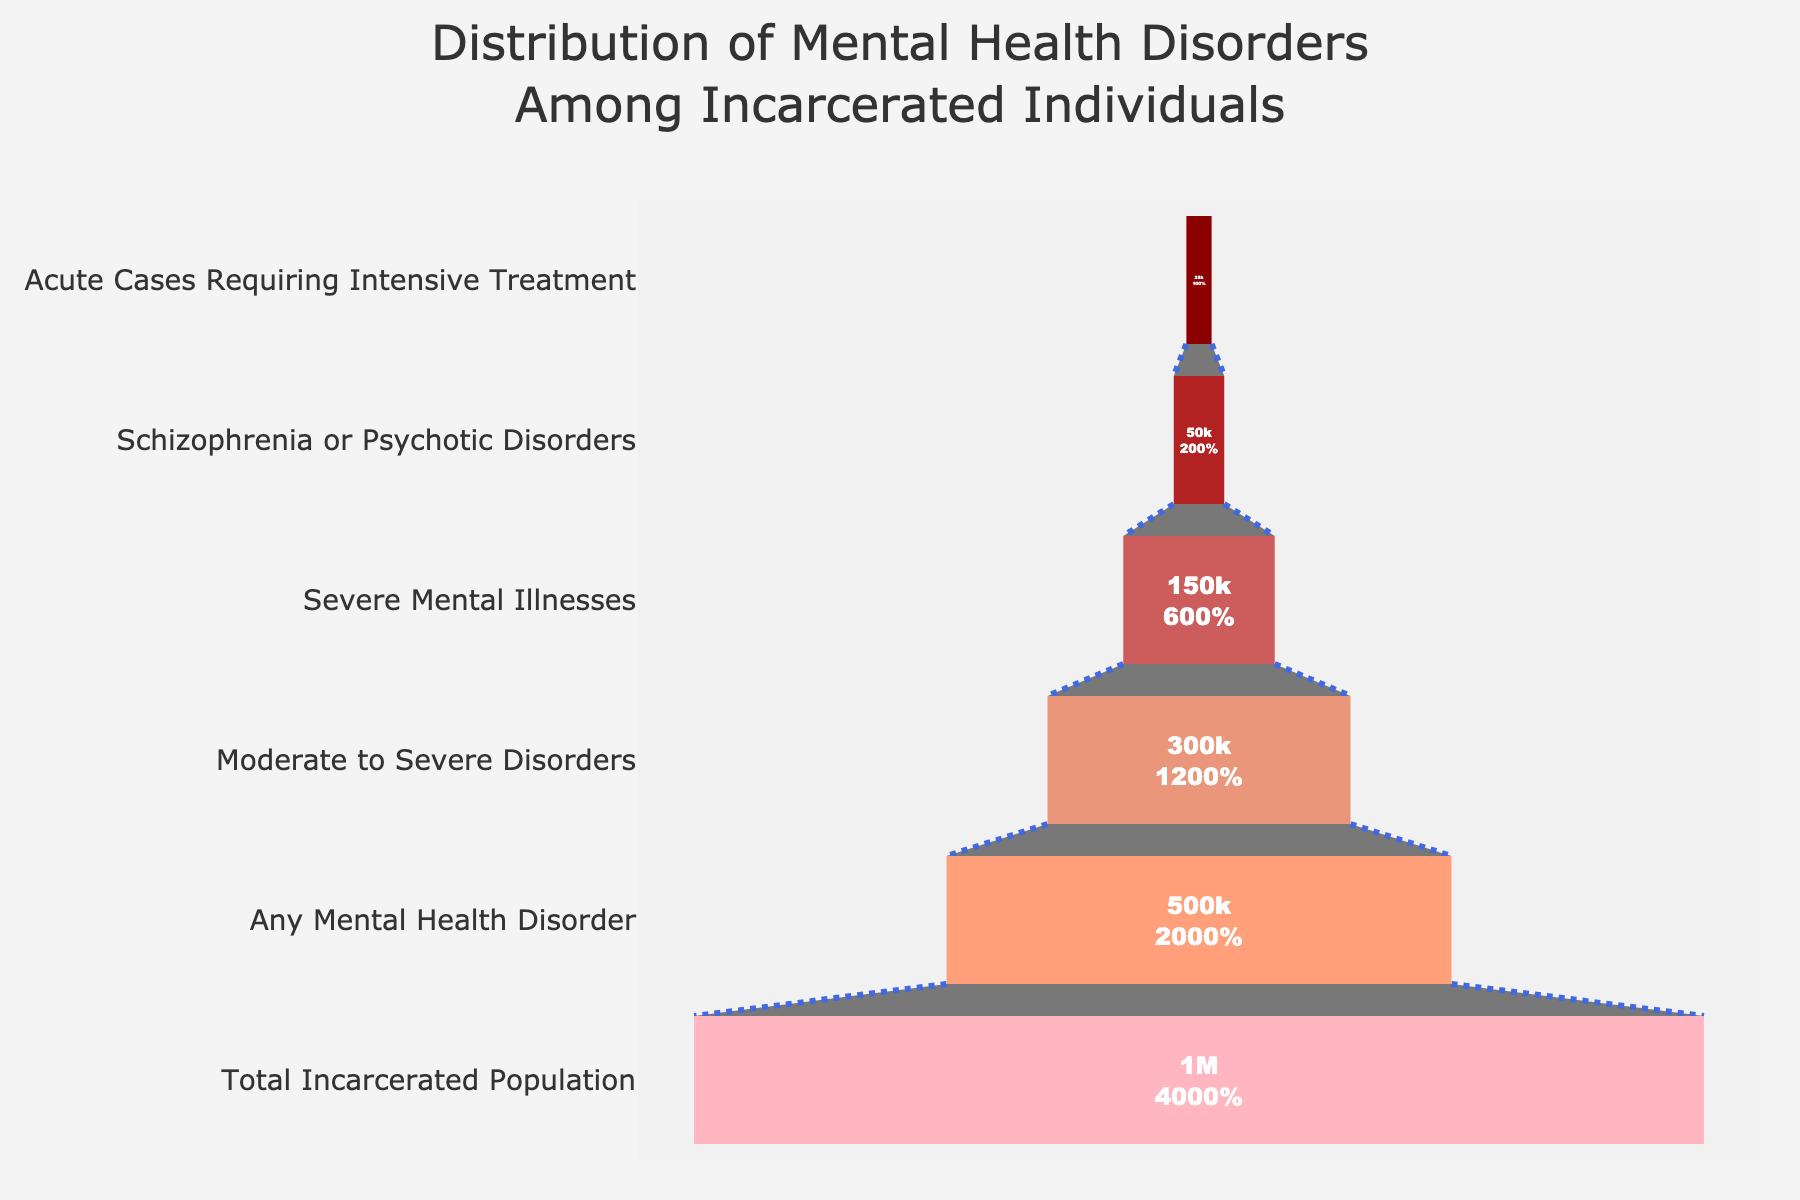What's the title of the figure? The title is located at the top of the chart and can be identified by a larger and bold font. It helps to quickly understand what the chart is about.
Answer: Distribution of Mental Health Disorders Among Incarcerated Individuals How many stages are represented in the funnel chart? Each stage can be identified by the labels along the y-axis, representing different classifications of mental health disorders. Counting these labels provides the total number of stages.
Answer: 6 What color is used to represent the "Any Mental Health Disorder" stage? The color of each stage is visually distinct. To find this, look at the color corresponding to the label "Any Mental Health Disorder".
Answer: Dark red How many individuals are in the "Severe Mental Illnesses" stage? Find the label "Severe Mental Illnesses" along the y-axis, and the corresponding value inside the stage's section will show the number of individuals.
Answer: 150,000 What percentage of the total incarcerated population has "Schizophrenia or Psychotic Disorders"? The percentage displayed inside the "Schizophrenia or Psychotic Disorders" stage can answer this directly.
Answer: 5% How many more individuals have "Moderate to Severe Disorders" compared to "Acute Cases Requiring Intensive Treatment"? Subtract the number of individuals in "Acute Cases Requiring Intensive Treatment" from those in "Moderate to Severe Disorders".
Answer: 275,000 (300,000 - 25,000) What stage has the highest number of individuals? Compare the values inside each stage. The stage with the largest number is the highest.
Answer: Total Incarcerated Population Which stage has the smallest proportion of individuals relative to the total incarcerated population? Look for the stage with the smallest value and check its percentage relative to the total population.
Answer: Acute Cases Requiring Intensive Treatment How many individuals with "Any Mental Health Disorder" do not have "Moderate to Severe Disorders"? Subtract the number of individuals in "Moderate to Severe Disorders" from those in "Any Mental Health Disorder".
Answer: 200,000 (500,000 - 300,000) What is the cumulative number of individuals from "Severe Mental Illnesses" to "Acute Cases Requiring Intensive Treatment"? Sum the individuals in "Severe Mental Illnesses", "Schizophrenia or Psychotic Disorders", and "Acute Cases Requiring Intensive Treatment".
Answer: 225,000 (150,000 + 50,000 + 25,000) 